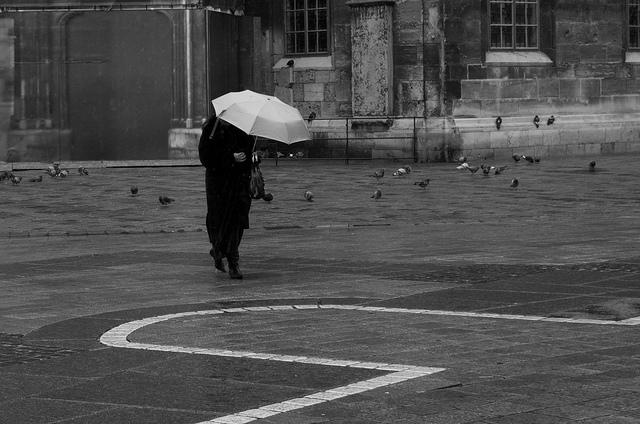Is there a truck in the street?
Concise answer only. No. Why is the boy carrying a umbrella?
Short answer required. Rain. Are there any birds in this photo?
Give a very brief answer. Yes. How many dogs are there?
Give a very brief answer. 0. Are there the same number of birds as children?
Answer briefly. No. What is the woman holding?
Answer briefly. Umbrella. What is the person holding?
Quick response, please. Umbrella. Can you see a face in the picture?
Answer briefly. No. Are there any birds in the picture?
Short answer required. Yes. Is it raining in this picture?
Short answer required. Yes. 